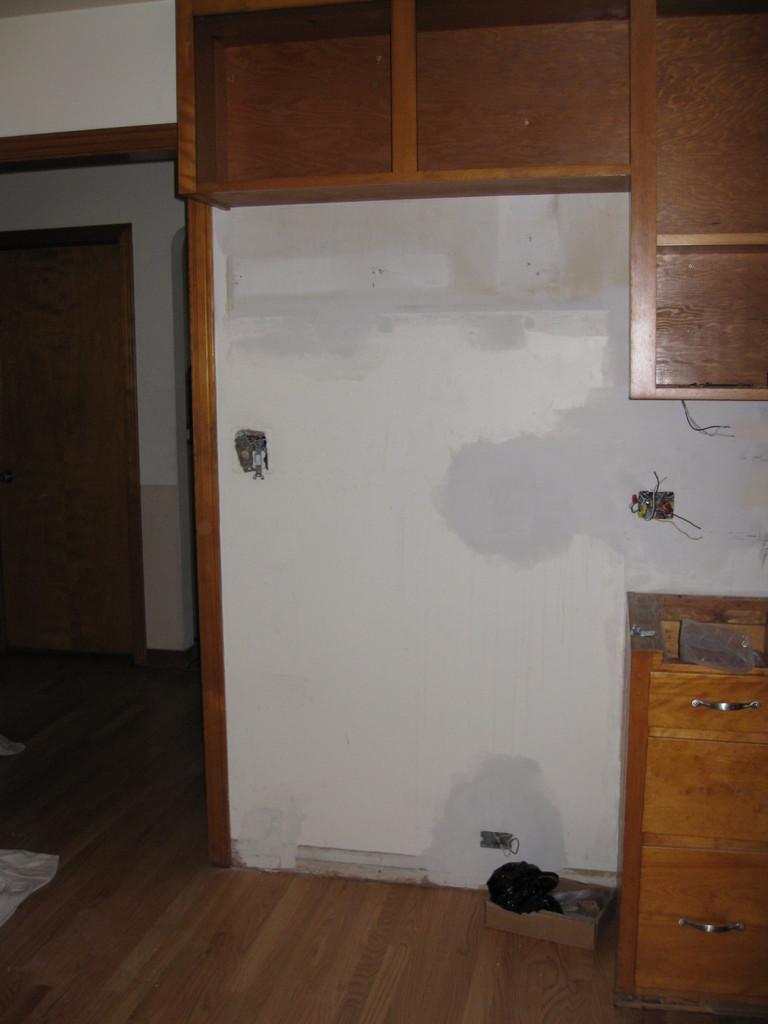In one or two sentences, can you explain what this image depicts? At the top there are wooden shelves, at the down there are cupboards. On the left side there is an entrance. 